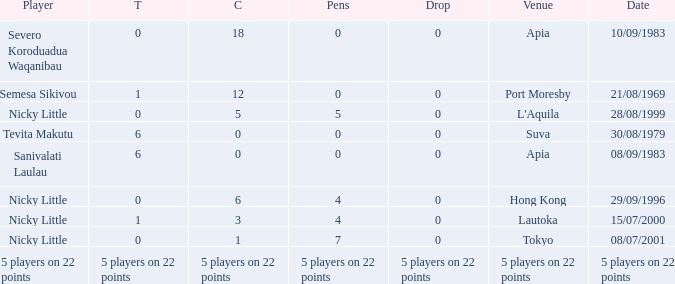How many conversions had 0 pens and 0 tries? 18.0. Can you parse all the data within this table? {'header': ['Player', 'T', 'C', 'Pens', 'Drop', 'Venue', 'Date'], 'rows': [['Severo Koroduadua Waqanibau', '0', '18', '0', '0', 'Apia', '10/09/1983'], ['Semesa Sikivou', '1', '12', '0', '0', 'Port Moresby', '21/08/1969'], ['Nicky Little', '0', '5', '5', '0', "L'Aquila", '28/08/1999'], ['Tevita Makutu', '6', '0', '0', '0', 'Suva', '30/08/1979'], ['Sanivalati Laulau', '6', '0', '0', '0', 'Apia', '08/09/1983'], ['Nicky Little', '0', '6', '4', '0', 'Hong Kong', '29/09/1996'], ['Nicky Little', '1', '3', '4', '0', 'Lautoka', '15/07/2000'], ['Nicky Little', '0', '1', '7', '0', 'Tokyo', '08/07/2001'], ['5 players on 22 points', '5 players on 22 points', '5 players on 22 points', '5 players on 22 points', '5 players on 22 points', '5 players on 22 points', '5 players on 22 points']]} 